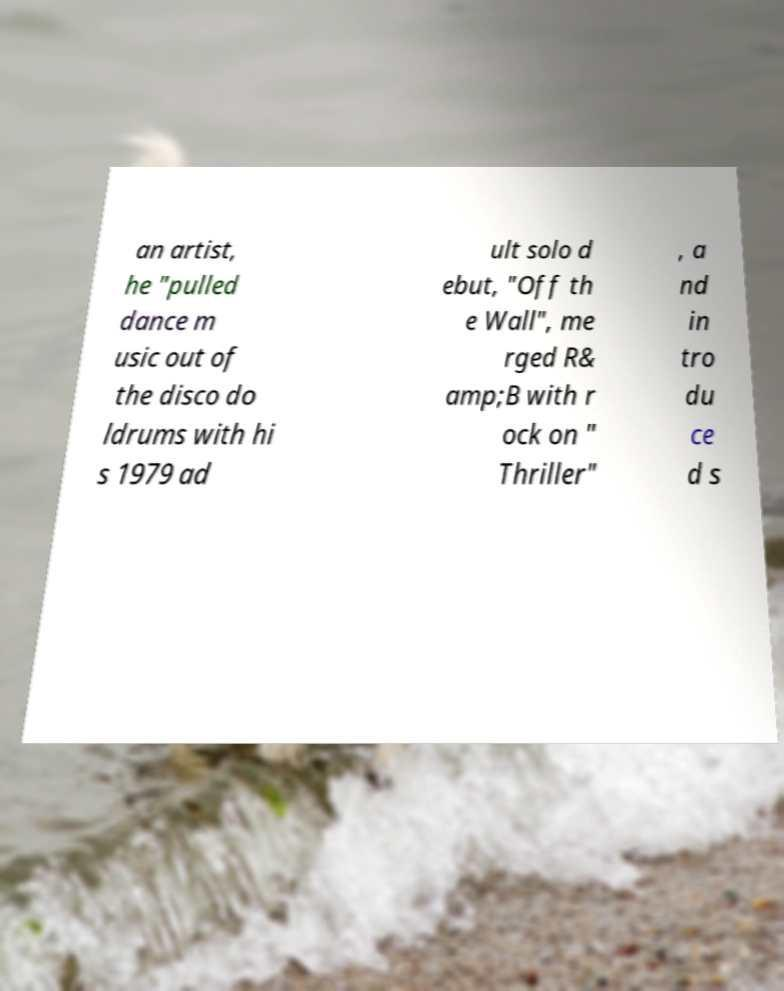Could you assist in decoding the text presented in this image and type it out clearly? an artist, he "pulled dance m usic out of the disco do ldrums with hi s 1979 ad ult solo d ebut, "Off th e Wall", me rged R& amp;B with r ock on " Thriller" , a nd in tro du ce d s 